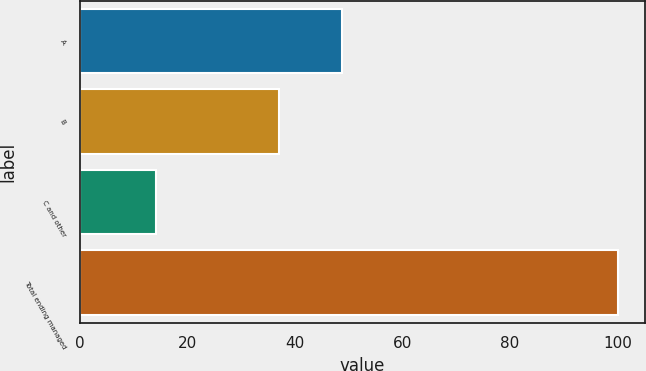<chart> <loc_0><loc_0><loc_500><loc_500><bar_chart><fcel>A<fcel>B<fcel>C and other<fcel>Total ending managed<nl><fcel>48.8<fcel>37<fcel>14.2<fcel>100<nl></chart> 